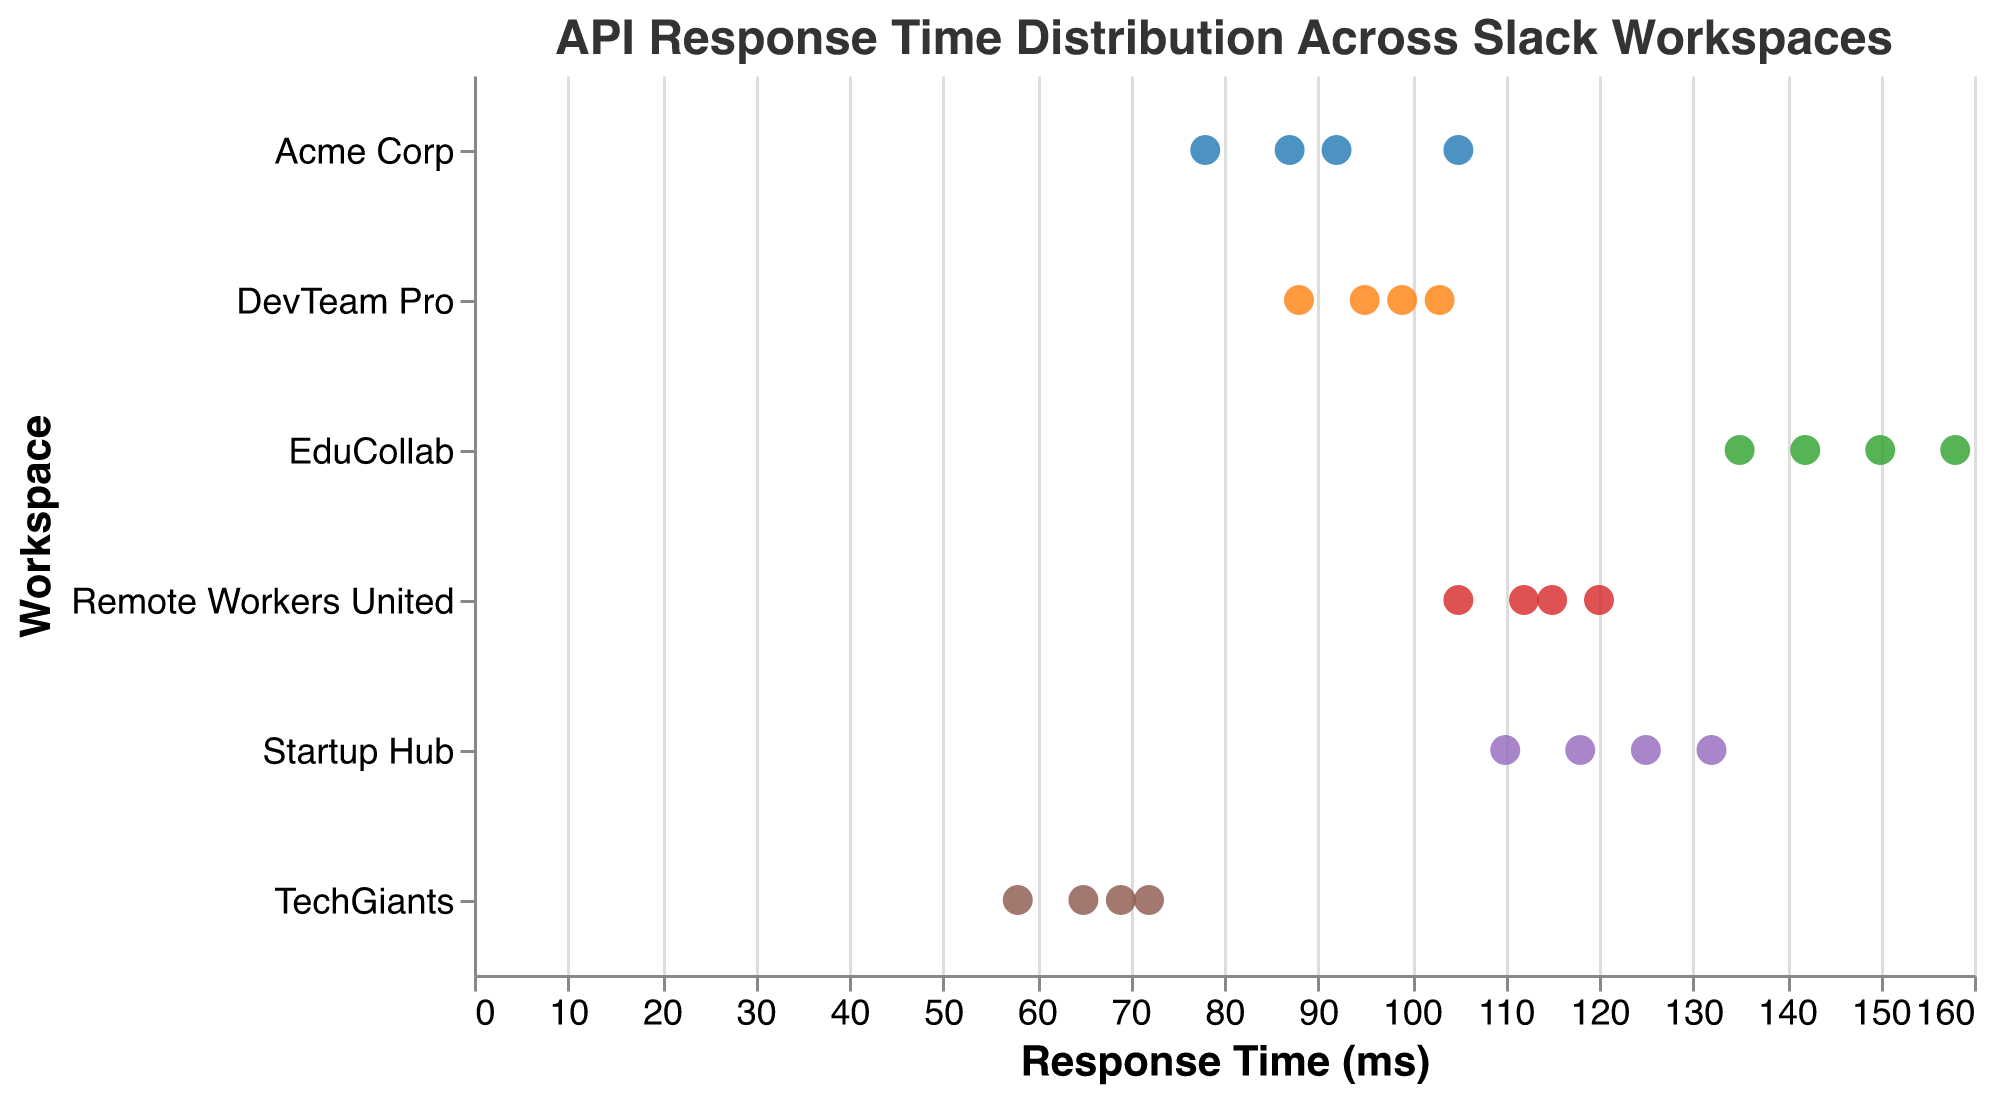What is the title of the plot? The title of the plot is displayed at the top and reads "API Response Time Distribution Across Slack Workspaces".
Answer: API Response Time Distribution Across Slack Workspaces What are the axes labels of the plot? The x-axis is labeled "Response Time (ms)" and the y-axis is labeled "Workspace". These labels are visible alongside their respective axes.
Answer: Response Time (ms), Workspace Which workspace has the smallest range of response times? By observing the spread of points along the x-axis for each workspace category on the y-axis, "TechGiants" has the smallest range, as its points are closely clustered.
Answer: TechGiants Which workspace has the highest response time, and what is its value? "EduCollab" has the highest response time. The highest response time in this workspace can be identified by locating the right-most point in the "EduCollab" category, which is 158 ms.
Answer: EduCollab, 158 ms Compare the average response times of "Acme Corp" and "TechGiants". Which workspace has a higher average? By averaging the response times for each workspace:
Acme Corp: (87 + 92 + 105 + 78) / 4 = 90.5 ms.
TechGiants: (65 + 72 + 58 + 69) / 4 = 66 ms.
Acme Corp has a higher average response time.
Answer: Acme Corp Which workspace has the lowest minimum response time? Locate the left-most point for each workspace. "TechGiants" has the lowest minimum response time at 58 ms.
Answer: TechGiants How many response times are recorded for "Remote Workers United"? The number of points visible for "Remote Workers United" denotes the count of recorded response times, which is 4.
Answer: 4 Identify three workspaces that have at least one response time exceeding 120 ms. Looking for data points beyond 120 ms on the x-axis, the workspaces "Startup Hub" (125, 132 ms), "EduCollab" (135, 142, 150, 158 ms), and "Remote Workers United" (120 ms) meet the criteria.
Answer: Startup Hub, EduCollab, Remote Workers United Which workspace has more evenly distributed response times, "Acme Corp" or "DevTeam Pro"? "Acme Corp"'s response times range between 78 and 105 ms, whereas "DevTeam Pro" ranges between 88 and 103 ms. Observing the spread and clustering, "Acme Corp" has a more even distribution.
Answer: Acme Corp 